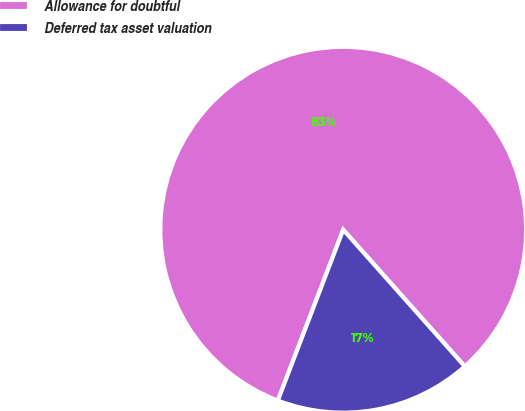Convert chart. <chart><loc_0><loc_0><loc_500><loc_500><pie_chart><fcel>Allowance for doubtful<fcel>Deferred tax asset valuation<nl><fcel>82.61%<fcel>17.39%<nl></chart> 